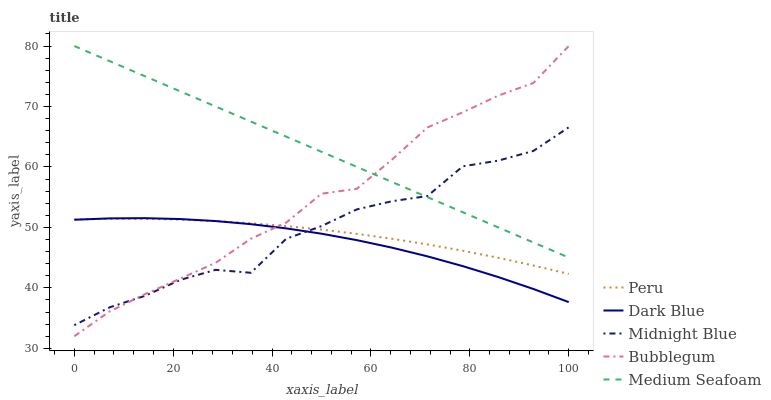Does Dark Blue have the minimum area under the curve?
Answer yes or no. Yes. Does Medium Seafoam have the maximum area under the curve?
Answer yes or no. Yes. Does Bubblegum have the minimum area under the curve?
Answer yes or no. No. Does Bubblegum have the maximum area under the curve?
Answer yes or no. No. Is Medium Seafoam the smoothest?
Answer yes or no. Yes. Is Midnight Blue the roughest?
Answer yes or no. Yes. Is Bubblegum the smoothest?
Answer yes or no. No. Is Bubblegum the roughest?
Answer yes or no. No. Does Midnight Blue have the lowest value?
Answer yes or no. No. Does Medium Seafoam have the highest value?
Answer yes or no. Yes. Does Midnight Blue have the highest value?
Answer yes or no. No. Is Dark Blue less than Medium Seafoam?
Answer yes or no. Yes. Is Medium Seafoam greater than Peru?
Answer yes or no. Yes. Does Dark Blue intersect Medium Seafoam?
Answer yes or no. No. 